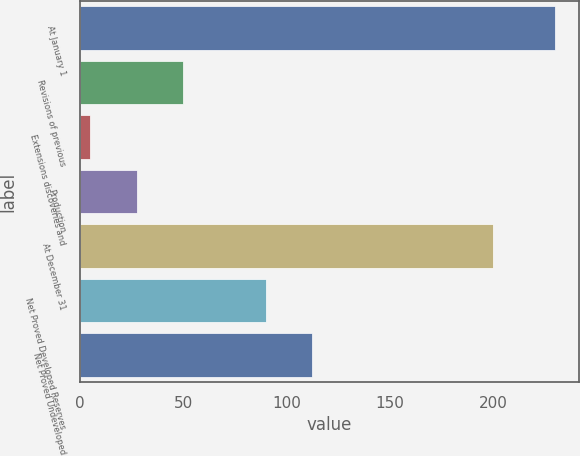<chart> <loc_0><loc_0><loc_500><loc_500><bar_chart><fcel>At January 1<fcel>Revisions of previous<fcel>Extensions discoveries and<fcel>Production<fcel>At December 31<fcel>Net Proved Developed Reserves<fcel>Net Proved Undeveloped<nl><fcel>230<fcel>50<fcel>5<fcel>27.5<fcel>200<fcel>90<fcel>112.5<nl></chart> 